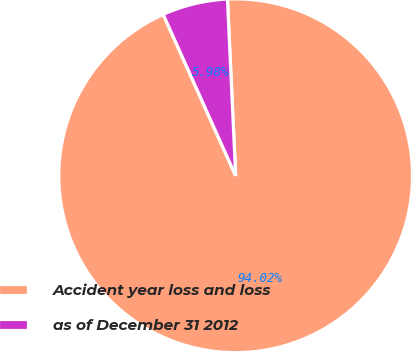<chart> <loc_0><loc_0><loc_500><loc_500><pie_chart><fcel>Accident year loss and loss<fcel>as of December 31 2012<nl><fcel>94.02%<fcel>5.98%<nl></chart> 